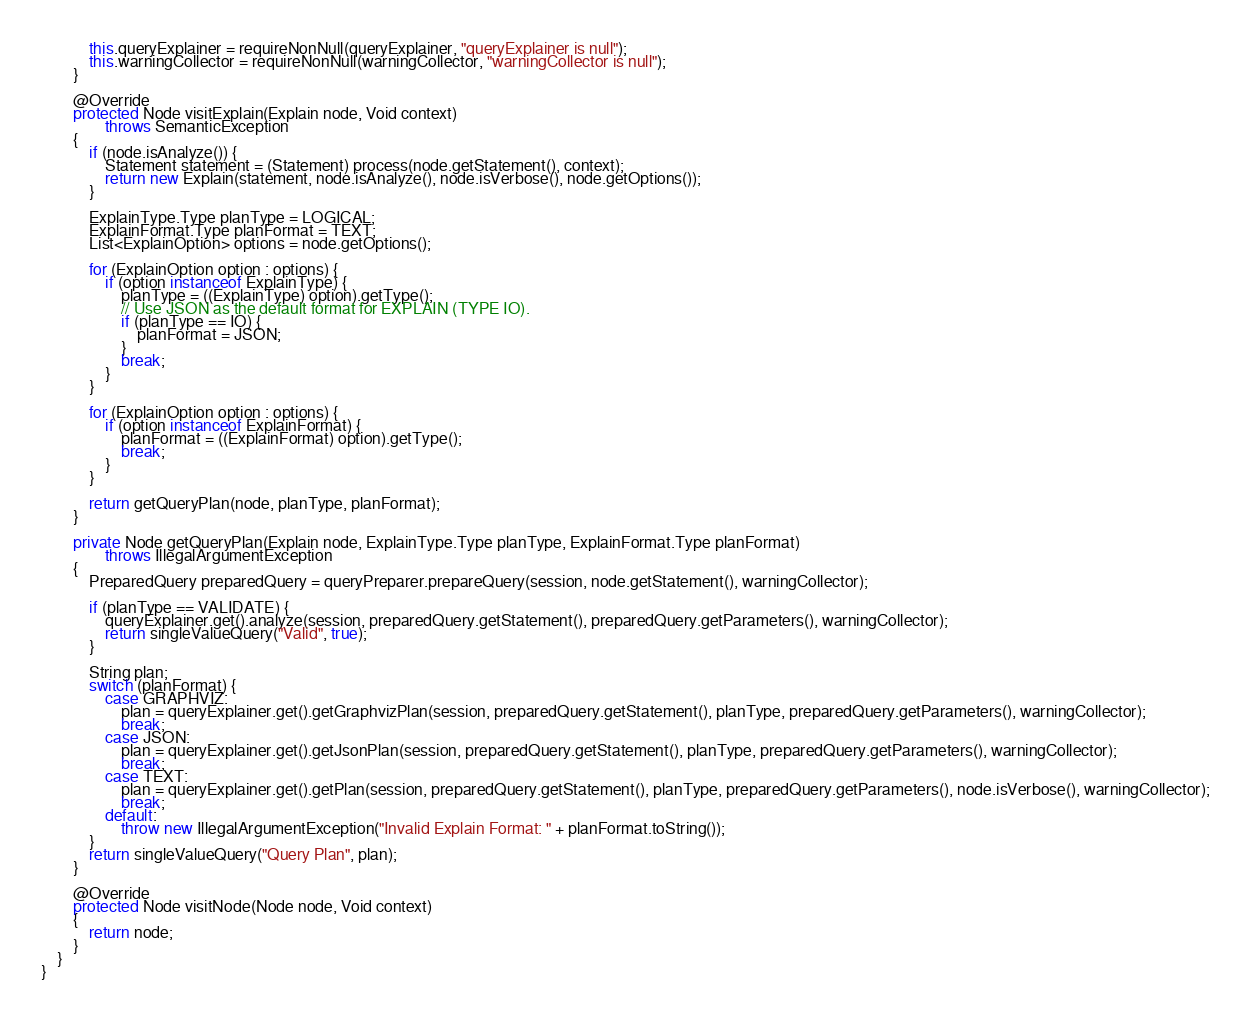Convert code to text. <code><loc_0><loc_0><loc_500><loc_500><_Java_>            this.queryExplainer = requireNonNull(queryExplainer, "queryExplainer is null");
            this.warningCollector = requireNonNull(warningCollector, "warningCollector is null");
        }

        @Override
        protected Node visitExplain(Explain node, Void context)
                throws SemanticException
        {
            if (node.isAnalyze()) {
                Statement statement = (Statement) process(node.getStatement(), context);
                return new Explain(statement, node.isAnalyze(), node.isVerbose(), node.getOptions());
            }

            ExplainType.Type planType = LOGICAL;
            ExplainFormat.Type planFormat = TEXT;
            List<ExplainOption> options = node.getOptions();

            for (ExplainOption option : options) {
                if (option instanceof ExplainType) {
                    planType = ((ExplainType) option).getType();
                    // Use JSON as the default format for EXPLAIN (TYPE IO).
                    if (planType == IO) {
                        planFormat = JSON;
                    }
                    break;
                }
            }

            for (ExplainOption option : options) {
                if (option instanceof ExplainFormat) {
                    planFormat = ((ExplainFormat) option).getType();
                    break;
                }
            }

            return getQueryPlan(node, planType, planFormat);
        }

        private Node getQueryPlan(Explain node, ExplainType.Type planType, ExplainFormat.Type planFormat)
                throws IllegalArgumentException
        {
            PreparedQuery preparedQuery = queryPreparer.prepareQuery(session, node.getStatement(), warningCollector);

            if (planType == VALIDATE) {
                queryExplainer.get().analyze(session, preparedQuery.getStatement(), preparedQuery.getParameters(), warningCollector);
                return singleValueQuery("Valid", true);
            }

            String plan;
            switch (planFormat) {
                case GRAPHVIZ:
                    plan = queryExplainer.get().getGraphvizPlan(session, preparedQuery.getStatement(), planType, preparedQuery.getParameters(), warningCollector);
                    break;
                case JSON:
                    plan = queryExplainer.get().getJsonPlan(session, preparedQuery.getStatement(), planType, preparedQuery.getParameters(), warningCollector);
                    break;
                case TEXT:
                    plan = queryExplainer.get().getPlan(session, preparedQuery.getStatement(), planType, preparedQuery.getParameters(), node.isVerbose(), warningCollector);
                    break;
                default:
                    throw new IllegalArgumentException("Invalid Explain Format: " + planFormat.toString());
            }
            return singleValueQuery("Query Plan", plan);
        }

        @Override
        protected Node visitNode(Node node, Void context)
        {
            return node;
        }
    }
}
</code> 